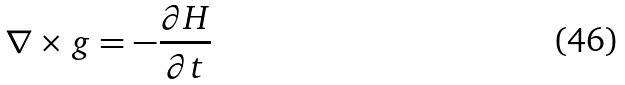Convert formula to latex. <formula><loc_0><loc_0><loc_500><loc_500>\nabla \times g = - \frac { \partial H } { \partial t }</formula> 